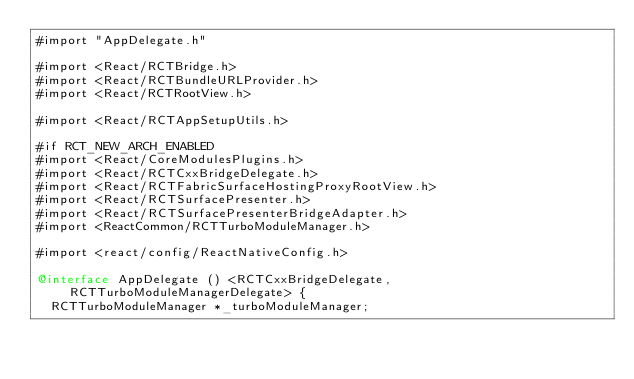Convert code to text. <code><loc_0><loc_0><loc_500><loc_500><_ObjectiveC_>#import "AppDelegate.h"

#import <React/RCTBridge.h>
#import <React/RCTBundleURLProvider.h>
#import <React/RCTRootView.h>

#import <React/RCTAppSetupUtils.h>

#if RCT_NEW_ARCH_ENABLED
#import <React/CoreModulesPlugins.h>
#import <React/RCTCxxBridgeDelegate.h>
#import <React/RCTFabricSurfaceHostingProxyRootView.h>
#import <React/RCTSurfacePresenter.h>
#import <React/RCTSurfacePresenterBridgeAdapter.h>
#import <ReactCommon/RCTTurboModuleManager.h>

#import <react/config/ReactNativeConfig.h>

@interface AppDelegate () <RCTCxxBridgeDelegate, RCTTurboModuleManagerDelegate> {
  RCTTurboModuleManager *_turboModuleManager;</code> 